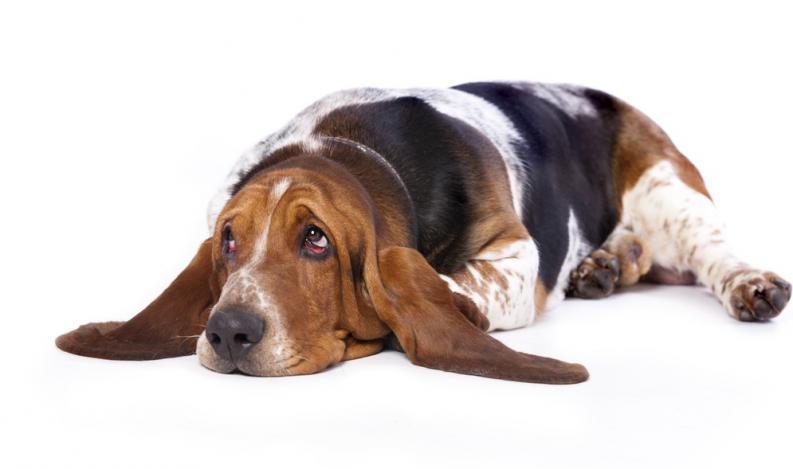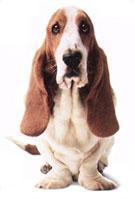The first image is the image on the left, the second image is the image on the right. For the images displayed, is the sentence "The rear end of the dog in the image on the left is resting on the ground." factually correct? Answer yes or no. Yes. The first image is the image on the left, the second image is the image on the right. Given the left and right images, does the statement "Each image contains only one dog, and one image shows a basset hound standing in profile on a white background." hold true? Answer yes or no. No. 